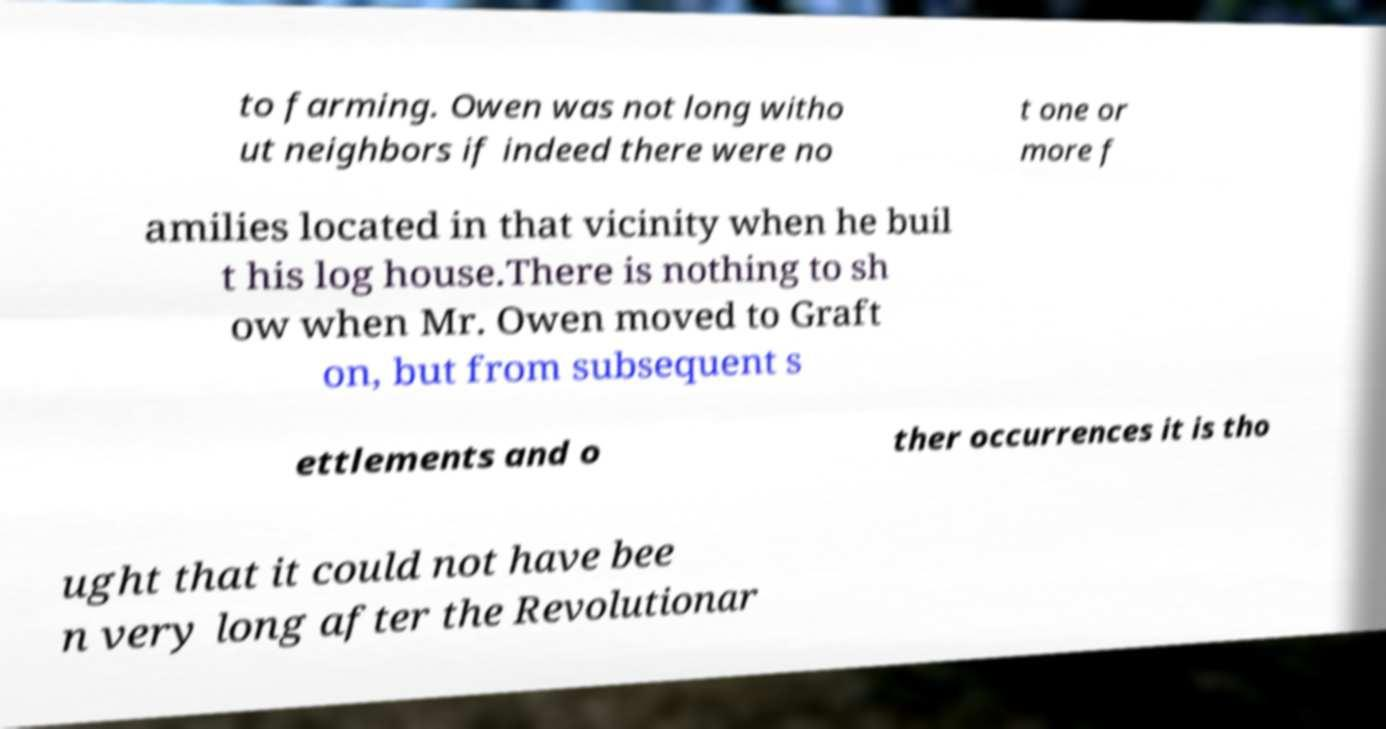Can you accurately transcribe the text from the provided image for me? to farming. Owen was not long witho ut neighbors if indeed there were no t one or more f amilies located in that vicinity when he buil t his log house.There is nothing to sh ow when Mr. Owen moved to Graft on, but from subsequent s ettlements and o ther occurrences it is tho ught that it could not have bee n very long after the Revolutionar 